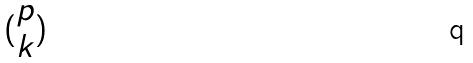Convert formula to latex. <formula><loc_0><loc_0><loc_500><loc_500>( \begin{matrix} p \\ k \end{matrix} )</formula> 